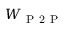Convert formula to latex. <formula><loc_0><loc_0><loc_500><loc_500>W _ { P 2 P }</formula> 